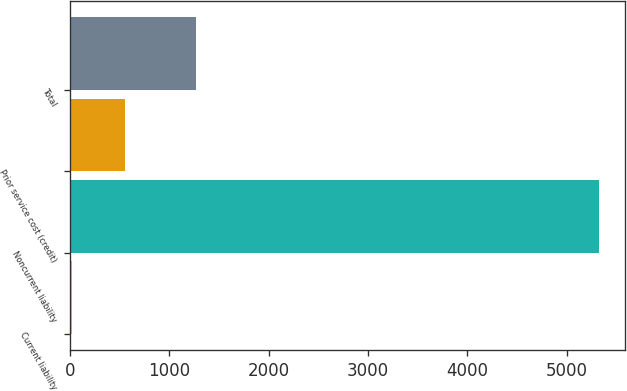Convert chart to OTSL. <chart><loc_0><loc_0><loc_500><loc_500><bar_chart><fcel>Current liability<fcel>Noncurrent liability<fcel>Prior service cost (credit)<fcel>Total<nl><fcel>21<fcel>5326<fcel>551.5<fcel>1268<nl></chart> 